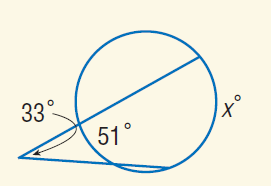Answer the mathemtical geometry problem and directly provide the correct option letter.
Question: Find x.
Choices: A: 33 B: 51 C: 84 D: 117 D 